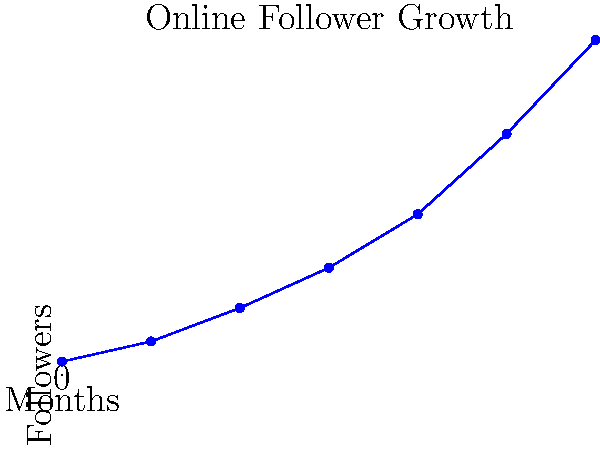As a Buddhist monk utilizing social media to spread teachings, you've been tracking your online follower growth. The graph shows your follower count over 6 months. What was the approximate increase in followers between the 3rd and 5th month? To find the increase in followers between the 3rd and 5th month, we need to:

1. Identify the follower count at the 3rd month (x-axis value 2):
   At 3 months, the follower count is approximately 5,000.

2. Identify the follower count at the 5th month (x-axis value 4):
   At 5 months, the follower count is approximately 12,000.

3. Calculate the difference:
   $12,000 - 5,000 = 7,000$

Therefore, the approximate increase in followers between the 3rd and 5th month is 7,000.
Answer: 7,000 followers 